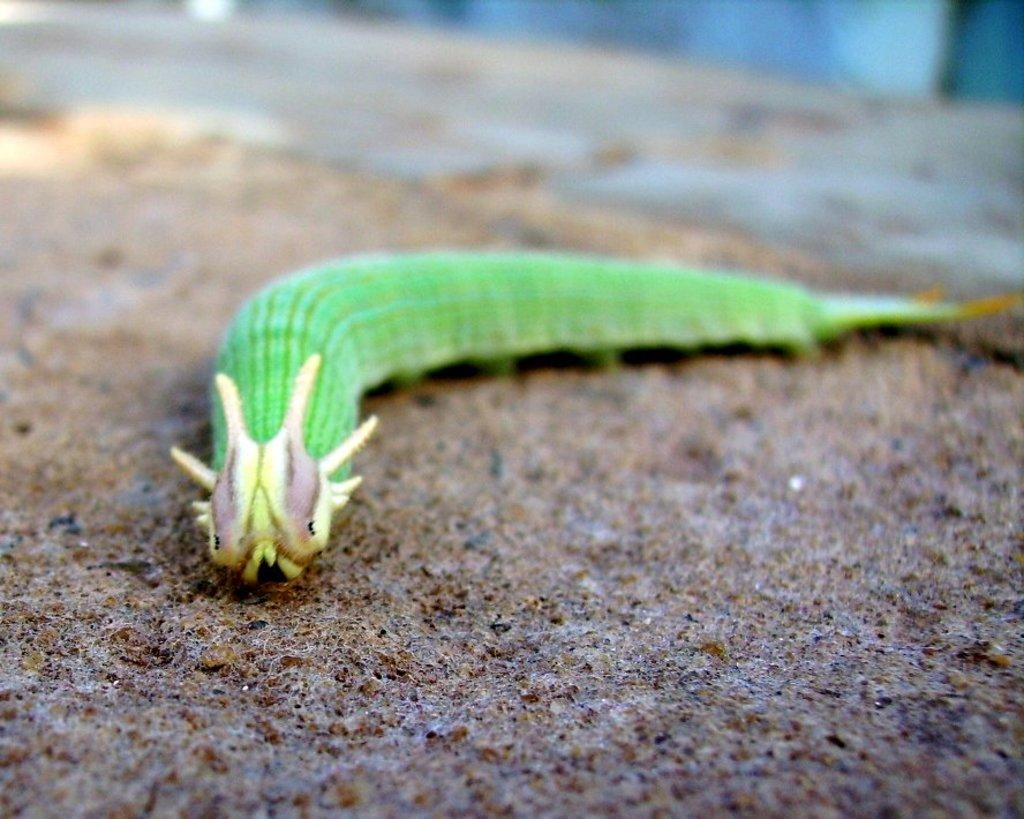What type of creature is present in the image? There is an insect in the image. What color is the insect? The insect is green in color. What is at the bottom of the image? There is sand at the bottom of the image. How would you describe the background of the image? The background of the image is blurred. What type of polish is being applied to the patch in the image? There is no polish or patch present in the image; it features an insect and sand. 